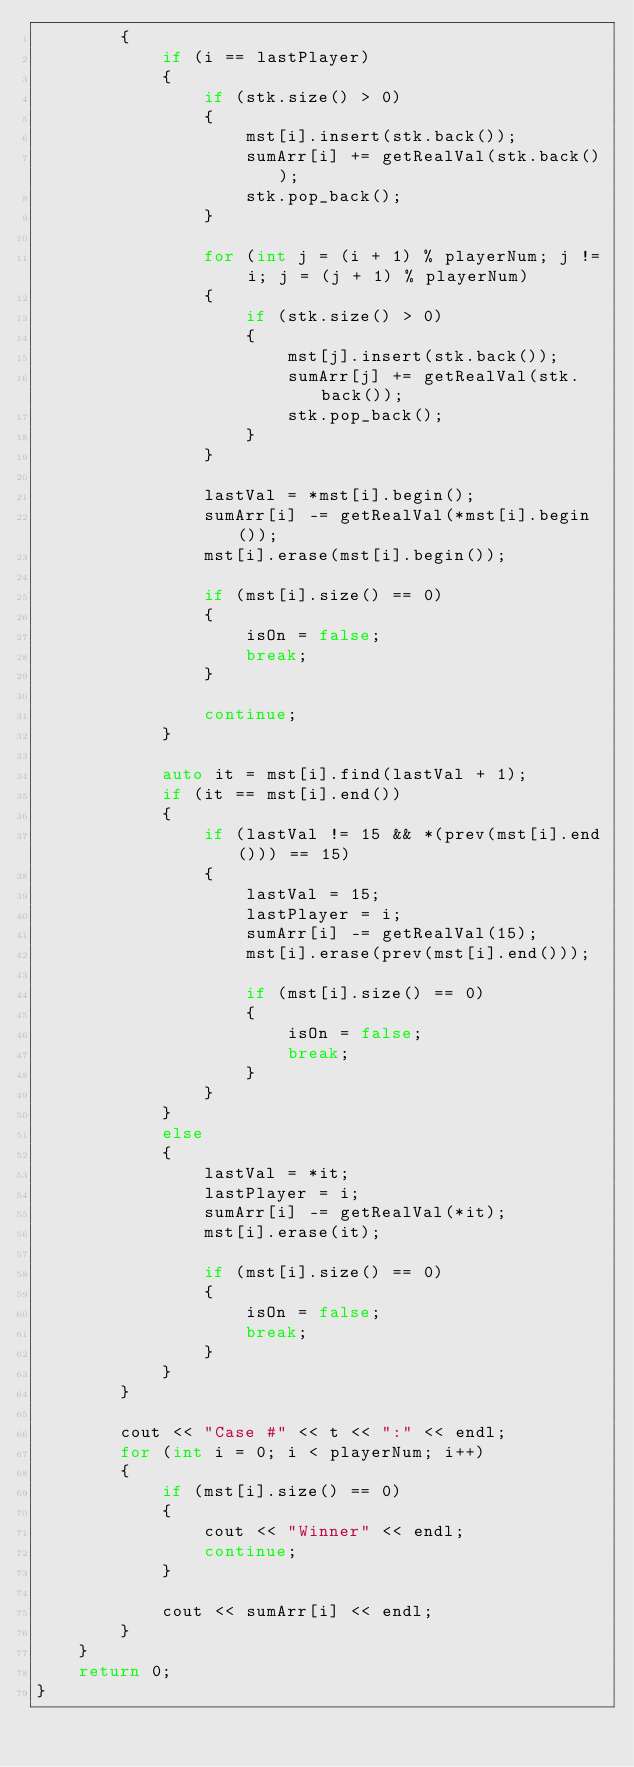Convert code to text. <code><loc_0><loc_0><loc_500><loc_500><_C++_>        {
            if (i == lastPlayer)
            {
                if (stk.size() > 0)
                {
                    mst[i].insert(stk.back());
                    sumArr[i] += getRealVal(stk.back());
                    stk.pop_back();
                }

                for (int j = (i + 1) % playerNum; j != i; j = (j + 1) % playerNum)
                {
                    if (stk.size() > 0)
                    {
                        mst[j].insert(stk.back());
                        sumArr[j] += getRealVal(stk.back());
                        stk.pop_back();
                    }
                }

                lastVal = *mst[i].begin();
                sumArr[i] -= getRealVal(*mst[i].begin());
                mst[i].erase(mst[i].begin());

                if (mst[i].size() == 0)
                {
                    isOn = false;
                    break;
                }

                continue;
            }

            auto it = mst[i].find(lastVal + 1);
            if (it == mst[i].end())
            {
                if (lastVal != 15 && *(prev(mst[i].end())) == 15)
                {
                    lastVal = 15;
                    lastPlayer = i;
                    sumArr[i] -= getRealVal(15);
                    mst[i].erase(prev(mst[i].end()));

                    if (mst[i].size() == 0)
                    {
                        isOn = false;
                        break;
                    }
                }
            }
            else
            {
                lastVal = *it;
                lastPlayer = i;
                sumArr[i] -= getRealVal(*it);
                mst[i].erase(it);

                if (mst[i].size() == 0)
                {
                    isOn = false;
                    break;
                }
            }
        }

        cout << "Case #" << t << ":" << endl;
        for (int i = 0; i < playerNum; i++)
        {
            if (mst[i].size() == 0)
            {
                cout << "Winner" << endl;
                continue;
            }

            cout << sumArr[i] << endl;
        }
    }
    return 0;
}</code> 